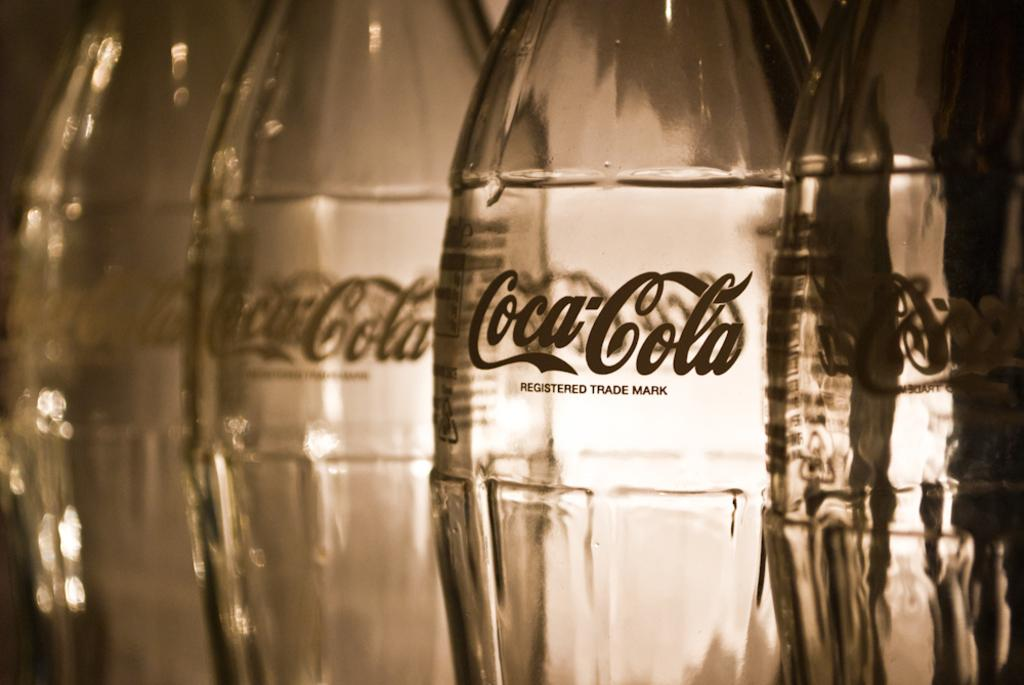What is the main focus of the image? The main focus of the image is highlighted with bottles. Can you describe the bottles in the image? Unfortunately, the provided facts do not give any details about the bottles, so we cannot describe them further. What type of corn is being harvested in the image? There is no corn present in the image; it is mainly highlighted with bottles. How much profit can be seen in the image? There is no information about profit in the image, as it is focused on bottles. 